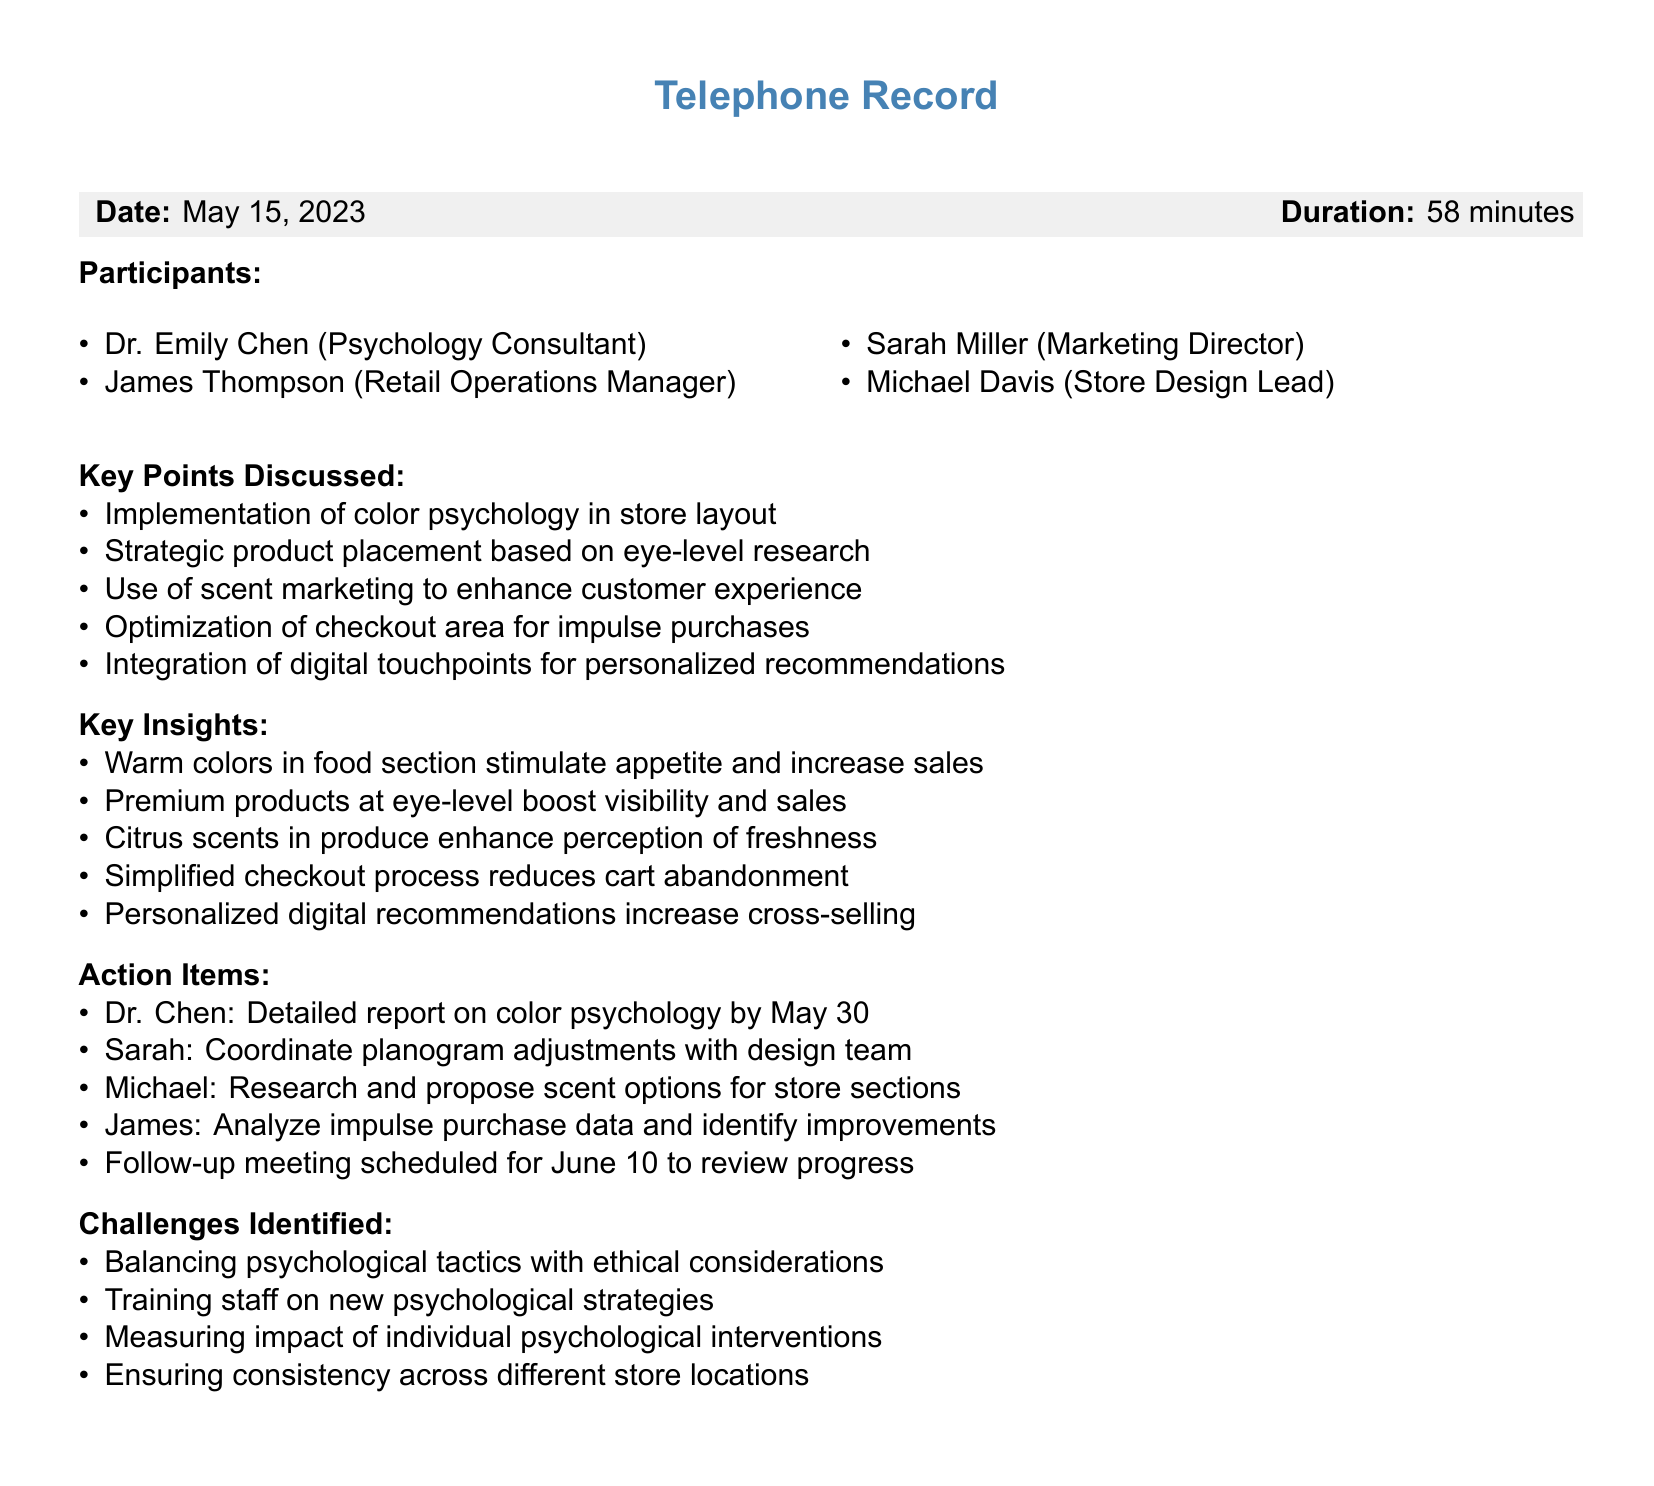What is the date of the conference call? The date of the conference call is listed in the document under the "Date" section.
Answer: May 15, 2023 How long did the conference call last? The duration of the conference call is provided in the document under the "Duration" section.
Answer: 58 minutes Who is the psychology consultant? The list of participants includes the role of psychology consultant, revealing the individual's name.
Answer: Dr. Emily Chen What strategy is used for optimizing impulse purchases? The document outlines several key points, one of which addresses impulse purchases directly.
Answer: Optimization of checkout area Which participant is responsible for the report on color psychology? Action items in the document specify who is responsible for various tasks, including this report.
Answer: Dr. Chen What scent is proposed to enhance the perception of freshness? The document mentions a specific scent associated with a particular product section.
Answer: Citrus scents What was one of the challenges identified during the call? The document lists challenges, revealing various concerns discussed during the meeting.
Answer: Balancing psychological tactics with ethical considerations When is the follow-up meeting scheduled? The follow-up meeting date is provided in the document as part of the action items.
Answer: June 10 